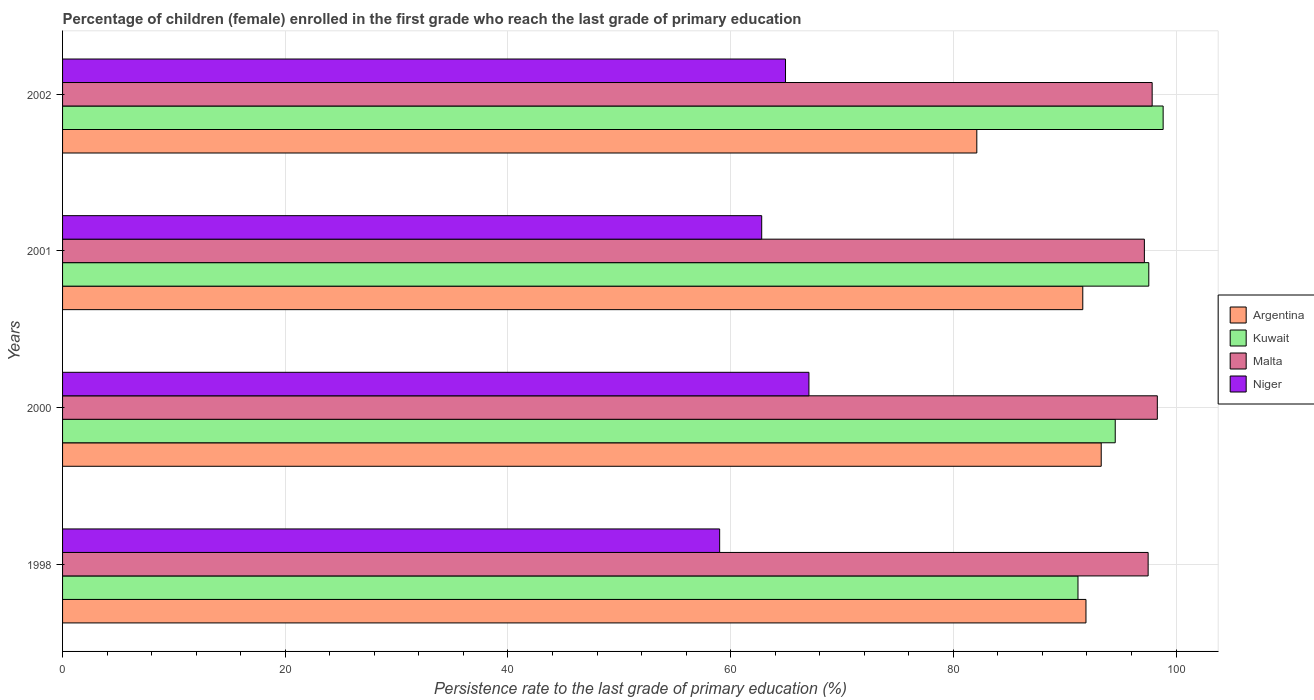How many different coloured bars are there?
Your response must be concise. 4. How many groups of bars are there?
Provide a succinct answer. 4. Are the number of bars per tick equal to the number of legend labels?
Ensure brevity in your answer.  Yes. Are the number of bars on each tick of the Y-axis equal?
Provide a succinct answer. Yes. In how many cases, is the number of bars for a given year not equal to the number of legend labels?
Offer a very short reply. 0. What is the persistence rate of children in Argentina in 2002?
Your answer should be compact. 82.11. Across all years, what is the maximum persistence rate of children in Malta?
Your response must be concise. 98.32. Across all years, what is the minimum persistence rate of children in Niger?
Provide a short and direct response. 59.02. In which year was the persistence rate of children in Niger minimum?
Give a very brief answer. 1998. What is the total persistence rate of children in Niger in the graph?
Ensure brevity in your answer.  253.77. What is the difference between the persistence rate of children in Argentina in 1998 and that in 2001?
Offer a terse response. 0.29. What is the difference between the persistence rate of children in Kuwait in 2000 and the persistence rate of children in Malta in 1998?
Offer a very short reply. -2.95. What is the average persistence rate of children in Malta per year?
Provide a succinct answer. 97.71. In the year 2002, what is the difference between the persistence rate of children in Kuwait and persistence rate of children in Malta?
Keep it short and to the point. 0.99. In how many years, is the persistence rate of children in Kuwait greater than 52 %?
Your response must be concise. 4. What is the ratio of the persistence rate of children in Niger in 2000 to that in 2001?
Make the answer very short. 1.07. Is the difference between the persistence rate of children in Kuwait in 2000 and 2002 greater than the difference between the persistence rate of children in Malta in 2000 and 2002?
Your answer should be very brief. No. What is the difference between the highest and the second highest persistence rate of children in Argentina?
Offer a very short reply. 1.37. What is the difference between the highest and the lowest persistence rate of children in Kuwait?
Make the answer very short. 7.65. Is it the case that in every year, the sum of the persistence rate of children in Malta and persistence rate of children in Argentina is greater than the sum of persistence rate of children in Niger and persistence rate of children in Kuwait?
Your answer should be compact. No. What does the 4th bar from the top in 2001 represents?
Offer a very short reply. Argentina. What does the 4th bar from the bottom in 2002 represents?
Offer a very short reply. Niger. Is it the case that in every year, the sum of the persistence rate of children in Niger and persistence rate of children in Kuwait is greater than the persistence rate of children in Malta?
Offer a terse response. Yes. How many bars are there?
Keep it short and to the point. 16. How many years are there in the graph?
Provide a short and direct response. 4. What is the difference between two consecutive major ticks on the X-axis?
Your answer should be compact. 20. Does the graph contain any zero values?
Provide a short and direct response. No. How are the legend labels stacked?
Your response must be concise. Vertical. What is the title of the graph?
Ensure brevity in your answer.  Percentage of children (female) enrolled in the first grade who reach the last grade of primary education. Does "Tajikistan" appear as one of the legend labels in the graph?
Provide a short and direct response. No. What is the label or title of the X-axis?
Your response must be concise. Persistence rate to the last grade of primary education (%). What is the label or title of the Y-axis?
Offer a very short reply. Years. What is the Persistence rate to the last grade of primary education (%) in Argentina in 1998?
Ensure brevity in your answer.  91.91. What is the Persistence rate to the last grade of primary education (%) of Kuwait in 1998?
Offer a terse response. 91.2. What is the Persistence rate to the last grade of primary education (%) in Malta in 1998?
Ensure brevity in your answer.  97.5. What is the Persistence rate to the last grade of primary education (%) in Niger in 1998?
Your response must be concise. 59.02. What is the Persistence rate to the last grade of primary education (%) of Argentina in 2000?
Your answer should be compact. 93.28. What is the Persistence rate to the last grade of primary education (%) of Kuwait in 2000?
Your answer should be compact. 94.54. What is the Persistence rate to the last grade of primary education (%) in Malta in 2000?
Make the answer very short. 98.32. What is the Persistence rate to the last grade of primary education (%) of Niger in 2000?
Offer a very short reply. 67.03. What is the Persistence rate to the last grade of primary education (%) in Argentina in 2001?
Keep it short and to the point. 91.63. What is the Persistence rate to the last grade of primary education (%) in Kuwait in 2001?
Keep it short and to the point. 97.56. What is the Persistence rate to the last grade of primary education (%) in Malta in 2001?
Keep it short and to the point. 97.16. What is the Persistence rate to the last grade of primary education (%) in Niger in 2001?
Your response must be concise. 62.79. What is the Persistence rate to the last grade of primary education (%) of Argentina in 2002?
Make the answer very short. 82.11. What is the Persistence rate to the last grade of primary education (%) of Kuwait in 2002?
Keep it short and to the point. 98.84. What is the Persistence rate to the last grade of primary education (%) in Malta in 2002?
Provide a succinct answer. 97.86. What is the Persistence rate to the last grade of primary education (%) in Niger in 2002?
Provide a succinct answer. 64.93. Across all years, what is the maximum Persistence rate to the last grade of primary education (%) in Argentina?
Give a very brief answer. 93.28. Across all years, what is the maximum Persistence rate to the last grade of primary education (%) of Kuwait?
Provide a short and direct response. 98.84. Across all years, what is the maximum Persistence rate to the last grade of primary education (%) of Malta?
Provide a short and direct response. 98.32. Across all years, what is the maximum Persistence rate to the last grade of primary education (%) of Niger?
Provide a succinct answer. 67.03. Across all years, what is the minimum Persistence rate to the last grade of primary education (%) of Argentina?
Offer a terse response. 82.11. Across all years, what is the minimum Persistence rate to the last grade of primary education (%) in Kuwait?
Your answer should be very brief. 91.2. Across all years, what is the minimum Persistence rate to the last grade of primary education (%) in Malta?
Provide a short and direct response. 97.16. Across all years, what is the minimum Persistence rate to the last grade of primary education (%) in Niger?
Provide a succinct answer. 59.02. What is the total Persistence rate to the last grade of primary education (%) in Argentina in the graph?
Your answer should be very brief. 358.94. What is the total Persistence rate to the last grade of primary education (%) in Kuwait in the graph?
Offer a very short reply. 382.14. What is the total Persistence rate to the last grade of primary education (%) of Malta in the graph?
Offer a terse response. 390.84. What is the total Persistence rate to the last grade of primary education (%) in Niger in the graph?
Your answer should be very brief. 253.77. What is the difference between the Persistence rate to the last grade of primary education (%) in Argentina in 1998 and that in 2000?
Provide a short and direct response. -1.37. What is the difference between the Persistence rate to the last grade of primary education (%) in Kuwait in 1998 and that in 2000?
Give a very brief answer. -3.35. What is the difference between the Persistence rate to the last grade of primary education (%) in Malta in 1998 and that in 2000?
Provide a succinct answer. -0.83. What is the difference between the Persistence rate to the last grade of primary education (%) in Niger in 1998 and that in 2000?
Provide a short and direct response. -8.02. What is the difference between the Persistence rate to the last grade of primary education (%) of Argentina in 1998 and that in 2001?
Your response must be concise. 0.29. What is the difference between the Persistence rate to the last grade of primary education (%) in Kuwait in 1998 and that in 2001?
Give a very brief answer. -6.36. What is the difference between the Persistence rate to the last grade of primary education (%) in Malta in 1998 and that in 2001?
Make the answer very short. 0.34. What is the difference between the Persistence rate to the last grade of primary education (%) of Niger in 1998 and that in 2001?
Your answer should be compact. -3.78. What is the difference between the Persistence rate to the last grade of primary education (%) in Argentina in 1998 and that in 2002?
Offer a terse response. 9.8. What is the difference between the Persistence rate to the last grade of primary education (%) of Kuwait in 1998 and that in 2002?
Give a very brief answer. -7.65. What is the difference between the Persistence rate to the last grade of primary education (%) of Malta in 1998 and that in 2002?
Provide a succinct answer. -0.36. What is the difference between the Persistence rate to the last grade of primary education (%) in Niger in 1998 and that in 2002?
Offer a terse response. -5.91. What is the difference between the Persistence rate to the last grade of primary education (%) of Argentina in 2000 and that in 2001?
Provide a short and direct response. 1.65. What is the difference between the Persistence rate to the last grade of primary education (%) in Kuwait in 2000 and that in 2001?
Make the answer very short. -3.01. What is the difference between the Persistence rate to the last grade of primary education (%) in Malta in 2000 and that in 2001?
Make the answer very short. 1.16. What is the difference between the Persistence rate to the last grade of primary education (%) of Niger in 2000 and that in 2001?
Your answer should be very brief. 4.24. What is the difference between the Persistence rate to the last grade of primary education (%) in Argentina in 2000 and that in 2002?
Your response must be concise. 11.17. What is the difference between the Persistence rate to the last grade of primary education (%) of Kuwait in 2000 and that in 2002?
Make the answer very short. -4.3. What is the difference between the Persistence rate to the last grade of primary education (%) in Malta in 2000 and that in 2002?
Give a very brief answer. 0.46. What is the difference between the Persistence rate to the last grade of primary education (%) in Niger in 2000 and that in 2002?
Your answer should be very brief. 2.1. What is the difference between the Persistence rate to the last grade of primary education (%) in Argentina in 2001 and that in 2002?
Provide a short and direct response. 9.52. What is the difference between the Persistence rate to the last grade of primary education (%) of Kuwait in 2001 and that in 2002?
Your answer should be very brief. -1.29. What is the difference between the Persistence rate to the last grade of primary education (%) in Malta in 2001 and that in 2002?
Your response must be concise. -0.7. What is the difference between the Persistence rate to the last grade of primary education (%) of Niger in 2001 and that in 2002?
Your response must be concise. -2.14. What is the difference between the Persistence rate to the last grade of primary education (%) of Argentina in 1998 and the Persistence rate to the last grade of primary education (%) of Kuwait in 2000?
Offer a terse response. -2.63. What is the difference between the Persistence rate to the last grade of primary education (%) in Argentina in 1998 and the Persistence rate to the last grade of primary education (%) in Malta in 2000?
Your response must be concise. -6.41. What is the difference between the Persistence rate to the last grade of primary education (%) in Argentina in 1998 and the Persistence rate to the last grade of primary education (%) in Niger in 2000?
Ensure brevity in your answer.  24.88. What is the difference between the Persistence rate to the last grade of primary education (%) in Kuwait in 1998 and the Persistence rate to the last grade of primary education (%) in Malta in 2000?
Your answer should be very brief. -7.13. What is the difference between the Persistence rate to the last grade of primary education (%) of Kuwait in 1998 and the Persistence rate to the last grade of primary education (%) of Niger in 2000?
Your answer should be very brief. 24.16. What is the difference between the Persistence rate to the last grade of primary education (%) of Malta in 1998 and the Persistence rate to the last grade of primary education (%) of Niger in 2000?
Ensure brevity in your answer.  30.46. What is the difference between the Persistence rate to the last grade of primary education (%) in Argentina in 1998 and the Persistence rate to the last grade of primary education (%) in Kuwait in 2001?
Provide a short and direct response. -5.64. What is the difference between the Persistence rate to the last grade of primary education (%) in Argentina in 1998 and the Persistence rate to the last grade of primary education (%) in Malta in 2001?
Provide a succinct answer. -5.25. What is the difference between the Persistence rate to the last grade of primary education (%) of Argentina in 1998 and the Persistence rate to the last grade of primary education (%) of Niger in 2001?
Ensure brevity in your answer.  29.12. What is the difference between the Persistence rate to the last grade of primary education (%) in Kuwait in 1998 and the Persistence rate to the last grade of primary education (%) in Malta in 2001?
Your response must be concise. -5.96. What is the difference between the Persistence rate to the last grade of primary education (%) in Kuwait in 1998 and the Persistence rate to the last grade of primary education (%) in Niger in 2001?
Offer a terse response. 28.4. What is the difference between the Persistence rate to the last grade of primary education (%) of Malta in 1998 and the Persistence rate to the last grade of primary education (%) of Niger in 2001?
Give a very brief answer. 34.71. What is the difference between the Persistence rate to the last grade of primary education (%) of Argentina in 1998 and the Persistence rate to the last grade of primary education (%) of Kuwait in 2002?
Give a very brief answer. -6.93. What is the difference between the Persistence rate to the last grade of primary education (%) of Argentina in 1998 and the Persistence rate to the last grade of primary education (%) of Malta in 2002?
Offer a terse response. -5.94. What is the difference between the Persistence rate to the last grade of primary education (%) in Argentina in 1998 and the Persistence rate to the last grade of primary education (%) in Niger in 2002?
Your response must be concise. 26.99. What is the difference between the Persistence rate to the last grade of primary education (%) of Kuwait in 1998 and the Persistence rate to the last grade of primary education (%) of Malta in 2002?
Provide a succinct answer. -6.66. What is the difference between the Persistence rate to the last grade of primary education (%) in Kuwait in 1998 and the Persistence rate to the last grade of primary education (%) in Niger in 2002?
Offer a very short reply. 26.27. What is the difference between the Persistence rate to the last grade of primary education (%) of Malta in 1998 and the Persistence rate to the last grade of primary education (%) of Niger in 2002?
Keep it short and to the point. 32.57. What is the difference between the Persistence rate to the last grade of primary education (%) of Argentina in 2000 and the Persistence rate to the last grade of primary education (%) of Kuwait in 2001?
Provide a succinct answer. -4.27. What is the difference between the Persistence rate to the last grade of primary education (%) in Argentina in 2000 and the Persistence rate to the last grade of primary education (%) in Malta in 2001?
Your answer should be compact. -3.88. What is the difference between the Persistence rate to the last grade of primary education (%) in Argentina in 2000 and the Persistence rate to the last grade of primary education (%) in Niger in 2001?
Ensure brevity in your answer.  30.49. What is the difference between the Persistence rate to the last grade of primary education (%) in Kuwait in 2000 and the Persistence rate to the last grade of primary education (%) in Malta in 2001?
Provide a succinct answer. -2.62. What is the difference between the Persistence rate to the last grade of primary education (%) in Kuwait in 2000 and the Persistence rate to the last grade of primary education (%) in Niger in 2001?
Keep it short and to the point. 31.75. What is the difference between the Persistence rate to the last grade of primary education (%) of Malta in 2000 and the Persistence rate to the last grade of primary education (%) of Niger in 2001?
Make the answer very short. 35.53. What is the difference between the Persistence rate to the last grade of primary education (%) in Argentina in 2000 and the Persistence rate to the last grade of primary education (%) in Kuwait in 2002?
Offer a terse response. -5.56. What is the difference between the Persistence rate to the last grade of primary education (%) of Argentina in 2000 and the Persistence rate to the last grade of primary education (%) of Malta in 2002?
Keep it short and to the point. -4.58. What is the difference between the Persistence rate to the last grade of primary education (%) of Argentina in 2000 and the Persistence rate to the last grade of primary education (%) of Niger in 2002?
Provide a short and direct response. 28.35. What is the difference between the Persistence rate to the last grade of primary education (%) in Kuwait in 2000 and the Persistence rate to the last grade of primary education (%) in Malta in 2002?
Ensure brevity in your answer.  -3.32. What is the difference between the Persistence rate to the last grade of primary education (%) of Kuwait in 2000 and the Persistence rate to the last grade of primary education (%) of Niger in 2002?
Your answer should be very brief. 29.61. What is the difference between the Persistence rate to the last grade of primary education (%) of Malta in 2000 and the Persistence rate to the last grade of primary education (%) of Niger in 2002?
Offer a very short reply. 33.39. What is the difference between the Persistence rate to the last grade of primary education (%) in Argentina in 2001 and the Persistence rate to the last grade of primary education (%) in Kuwait in 2002?
Offer a terse response. -7.22. What is the difference between the Persistence rate to the last grade of primary education (%) of Argentina in 2001 and the Persistence rate to the last grade of primary education (%) of Malta in 2002?
Offer a very short reply. -6.23. What is the difference between the Persistence rate to the last grade of primary education (%) in Argentina in 2001 and the Persistence rate to the last grade of primary education (%) in Niger in 2002?
Your response must be concise. 26.7. What is the difference between the Persistence rate to the last grade of primary education (%) of Kuwait in 2001 and the Persistence rate to the last grade of primary education (%) of Malta in 2002?
Keep it short and to the point. -0.3. What is the difference between the Persistence rate to the last grade of primary education (%) of Kuwait in 2001 and the Persistence rate to the last grade of primary education (%) of Niger in 2002?
Your response must be concise. 32.63. What is the difference between the Persistence rate to the last grade of primary education (%) of Malta in 2001 and the Persistence rate to the last grade of primary education (%) of Niger in 2002?
Give a very brief answer. 32.23. What is the average Persistence rate to the last grade of primary education (%) of Argentina per year?
Your response must be concise. 89.73. What is the average Persistence rate to the last grade of primary education (%) in Kuwait per year?
Your answer should be compact. 95.54. What is the average Persistence rate to the last grade of primary education (%) in Malta per year?
Provide a succinct answer. 97.71. What is the average Persistence rate to the last grade of primary education (%) of Niger per year?
Make the answer very short. 63.44. In the year 1998, what is the difference between the Persistence rate to the last grade of primary education (%) of Argentina and Persistence rate to the last grade of primary education (%) of Kuwait?
Offer a very short reply. 0.72. In the year 1998, what is the difference between the Persistence rate to the last grade of primary education (%) of Argentina and Persistence rate to the last grade of primary education (%) of Malta?
Keep it short and to the point. -5.58. In the year 1998, what is the difference between the Persistence rate to the last grade of primary education (%) of Argentina and Persistence rate to the last grade of primary education (%) of Niger?
Keep it short and to the point. 32.9. In the year 1998, what is the difference between the Persistence rate to the last grade of primary education (%) in Kuwait and Persistence rate to the last grade of primary education (%) in Malta?
Your answer should be very brief. -6.3. In the year 1998, what is the difference between the Persistence rate to the last grade of primary education (%) in Kuwait and Persistence rate to the last grade of primary education (%) in Niger?
Your answer should be very brief. 32.18. In the year 1998, what is the difference between the Persistence rate to the last grade of primary education (%) in Malta and Persistence rate to the last grade of primary education (%) in Niger?
Keep it short and to the point. 38.48. In the year 2000, what is the difference between the Persistence rate to the last grade of primary education (%) in Argentina and Persistence rate to the last grade of primary education (%) in Kuwait?
Make the answer very short. -1.26. In the year 2000, what is the difference between the Persistence rate to the last grade of primary education (%) in Argentina and Persistence rate to the last grade of primary education (%) in Malta?
Give a very brief answer. -5.04. In the year 2000, what is the difference between the Persistence rate to the last grade of primary education (%) of Argentina and Persistence rate to the last grade of primary education (%) of Niger?
Ensure brevity in your answer.  26.25. In the year 2000, what is the difference between the Persistence rate to the last grade of primary education (%) of Kuwait and Persistence rate to the last grade of primary education (%) of Malta?
Your response must be concise. -3.78. In the year 2000, what is the difference between the Persistence rate to the last grade of primary education (%) in Kuwait and Persistence rate to the last grade of primary education (%) in Niger?
Give a very brief answer. 27.51. In the year 2000, what is the difference between the Persistence rate to the last grade of primary education (%) of Malta and Persistence rate to the last grade of primary education (%) of Niger?
Your answer should be compact. 31.29. In the year 2001, what is the difference between the Persistence rate to the last grade of primary education (%) of Argentina and Persistence rate to the last grade of primary education (%) of Kuwait?
Make the answer very short. -5.93. In the year 2001, what is the difference between the Persistence rate to the last grade of primary education (%) of Argentina and Persistence rate to the last grade of primary education (%) of Malta?
Provide a succinct answer. -5.53. In the year 2001, what is the difference between the Persistence rate to the last grade of primary education (%) of Argentina and Persistence rate to the last grade of primary education (%) of Niger?
Your answer should be compact. 28.84. In the year 2001, what is the difference between the Persistence rate to the last grade of primary education (%) of Kuwait and Persistence rate to the last grade of primary education (%) of Malta?
Your answer should be compact. 0.4. In the year 2001, what is the difference between the Persistence rate to the last grade of primary education (%) in Kuwait and Persistence rate to the last grade of primary education (%) in Niger?
Your response must be concise. 34.76. In the year 2001, what is the difference between the Persistence rate to the last grade of primary education (%) in Malta and Persistence rate to the last grade of primary education (%) in Niger?
Your answer should be very brief. 34.37. In the year 2002, what is the difference between the Persistence rate to the last grade of primary education (%) in Argentina and Persistence rate to the last grade of primary education (%) in Kuwait?
Offer a terse response. -16.73. In the year 2002, what is the difference between the Persistence rate to the last grade of primary education (%) of Argentina and Persistence rate to the last grade of primary education (%) of Malta?
Your response must be concise. -15.75. In the year 2002, what is the difference between the Persistence rate to the last grade of primary education (%) in Argentina and Persistence rate to the last grade of primary education (%) in Niger?
Provide a short and direct response. 17.18. In the year 2002, what is the difference between the Persistence rate to the last grade of primary education (%) of Kuwait and Persistence rate to the last grade of primary education (%) of Malta?
Give a very brief answer. 0.99. In the year 2002, what is the difference between the Persistence rate to the last grade of primary education (%) of Kuwait and Persistence rate to the last grade of primary education (%) of Niger?
Your answer should be very brief. 33.92. In the year 2002, what is the difference between the Persistence rate to the last grade of primary education (%) in Malta and Persistence rate to the last grade of primary education (%) in Niger?
Offer a very short reply. 32.93. What is the ratio of the Persistence rate to the last grade of primary education (%) in Argentina in 1998 to that in 2000?
Ensure brevity in your answer.  0.99. What is the ratio of the Persistence rate to the last grade of primary education (%) of Kuwait in 1998 to that in 2000?
Offer a terse response. 0.96. What is the ratio of the Persistence rate to the last grade of primary education (%) of Niger in 1998 to that in 2000?
Keep it short and to the point. 0.88. What is the ratio of the Persistence rate to the last grade of primary education (%) of Kuwait in 1998 to that in 2001?
Ensure brevity in your answer.  0.93. What is the ratio of the Persistence rate to the last grade of primary education (%) of Malta in 1998 to that in 2001?
Make the answer very short. 1. What is the ratio of the Persistence rate to the last grade of primary education (%) in Niger in 1998 to that in 2001?
Your answer should be very brief. 0.94. What is the ratio of the Persistence rate to the last grade of primary education (%) in Argentina in 1998 to that in 2002?
Your response must be concise. 1.12. What is the ratio of the Persistence rate to the last grade of primary education (%) in Kuwait in 1998 to that in 2002?
Ensure brevity in your answer.  0.92. What is the ratio of the Persistence rate to the last grade of primary education (%) of Niger in 1998 to that in 2002?
Keep it short and to the point. 0.91. What is the ratio of the Persistence rate to the last grade of primary education (%) in Argentina in 2000 to that in 2001?
Offer a very short reply. 1.02. What is the ratio of the Persistence rate to the last grade of primary education (%) in Kuwait in 2000 to that in 2001?
Ensure brevity in your answer.  0.97. What is the ratio of the Persistence rate to the last grade of primary education (%) in Malta in 2000 to that in 2001?
Your answer should be compact. 1.01. What is the ratio of the Persistence rate to the last grade of primary education (%) in Niger in 2000 to that in 2001?
Provide a succinct answer. 1.07. What is the ratio of the Persistence rate to the last grade of primary education (%) in Argentina in 2000 to that in 2002?
Your answer should be very brief. 1.14. What is the ratio of the Persistence rate to the last grade of primary education (%) of Kuwait in 2000 to that in 2002?
Offer a very short reply. 0.96. What is the ratio of the Persistence rate to the last grade of primary education (%) in Malta in 2000 to that in 2002?
Your answer should be very brief. 1. What is the ratio of the Persistence rate to the last grade of primary education (%) in Niger in 2000 to that in 2002?
Your answer should be very brief. 1.03. What is the ratio of the Persistence rate to the last grade of primary education (%) in Argentina in 2001 to that in 2002?
Your answer should be very brief. 1.12. What is the ratio of the Persistence rate to the last grade of primary education (%) of Niger in 2001 to that in 2002?
Make the answer very short. 0.97. What is the difference between the highest and the second highest Persistence rate to the last grade of primary education (%) in Argentina?
Offer a terse response. 1.37. What is the difference between the highest and the second highest Persistence rate to the last grade of primary education (%) in Kuwait?
Your answer should be very brief. 1.29. What is the difference between the highest and the second highest Persistence rate to the last grade of primary education (%) of Malta?
Provide a succinct answer. 0.46. What is the difference between the highest and the second highest Persistence rate to the last grade of primary education (%) of Niger?
Give a very brief answer. 2.1. What is the difference between the highest and the lowest Persistence rate to the last grade of primary education (%) of Argentina?
Ensure brevity in your answer.  11.17. What is the difference between the highest and the lowest Persistence rate to the last grade of primary education (%) of Kuwait?
Offer a very short reply. 7.65. What is the difference between the highest and the lowest Persistence rate to the last grade of primary education (%) in Malta?
Make the answer very short. 1.16. What is the difference between the highest and the lowest Persistence rate to the last grade of primary education (%) of Niger?
Provide a short and direct response. 8.02. 